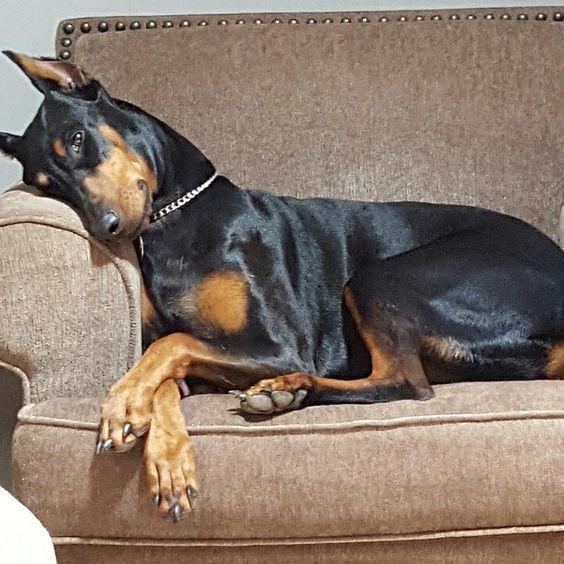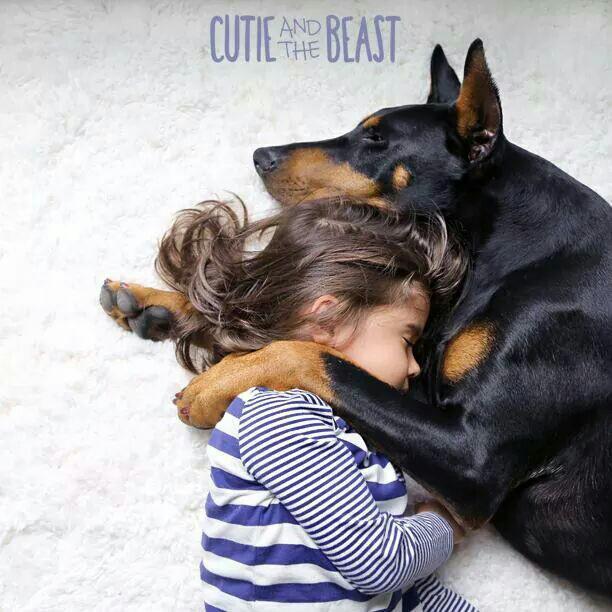The first image is the image on the left, the second image is the image on the right. Considering the images on both sides, is "All dogs shown are sleeping on their backs with their front paws bent, and the dog on the right has its head flung back and its muzzle at the lower right." valid? Answer yes or no. No. 